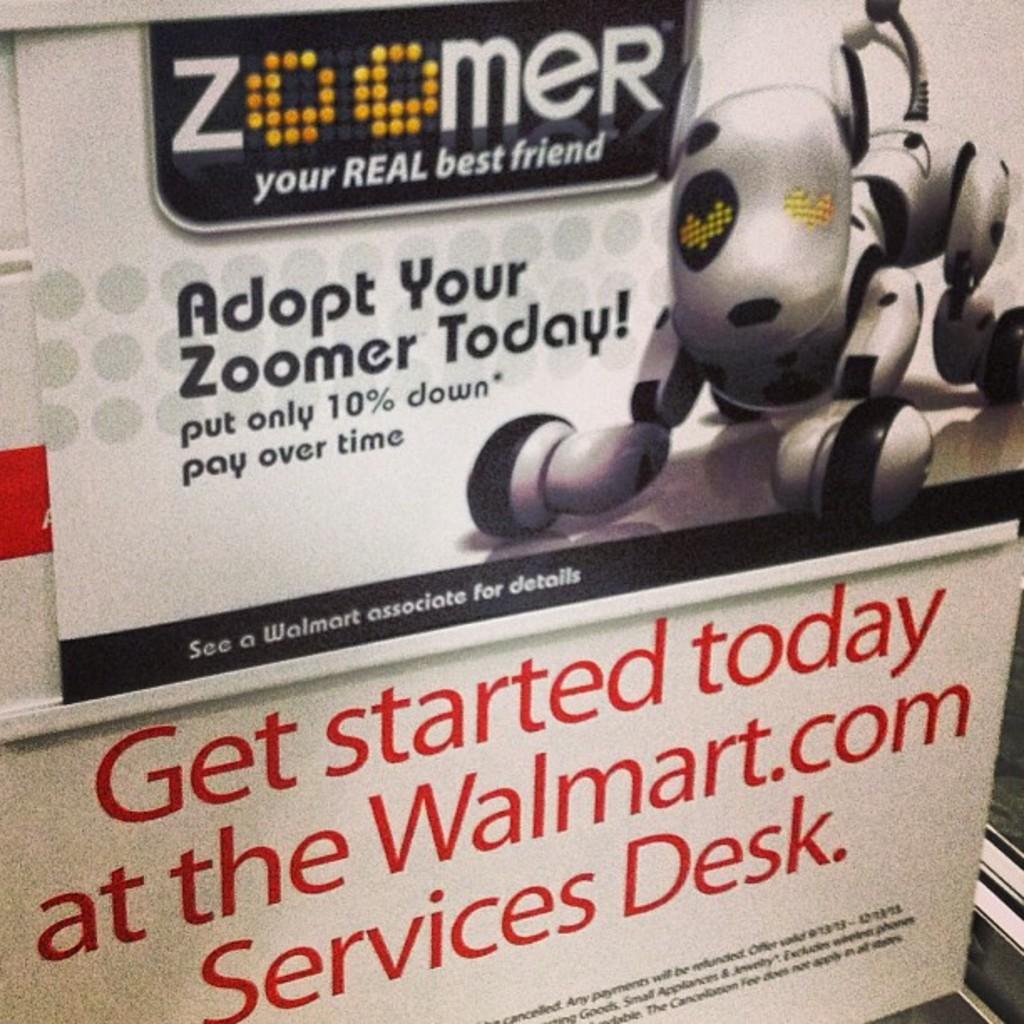What down payment can you put down on this product?
Offer a very short reply. 10%. 